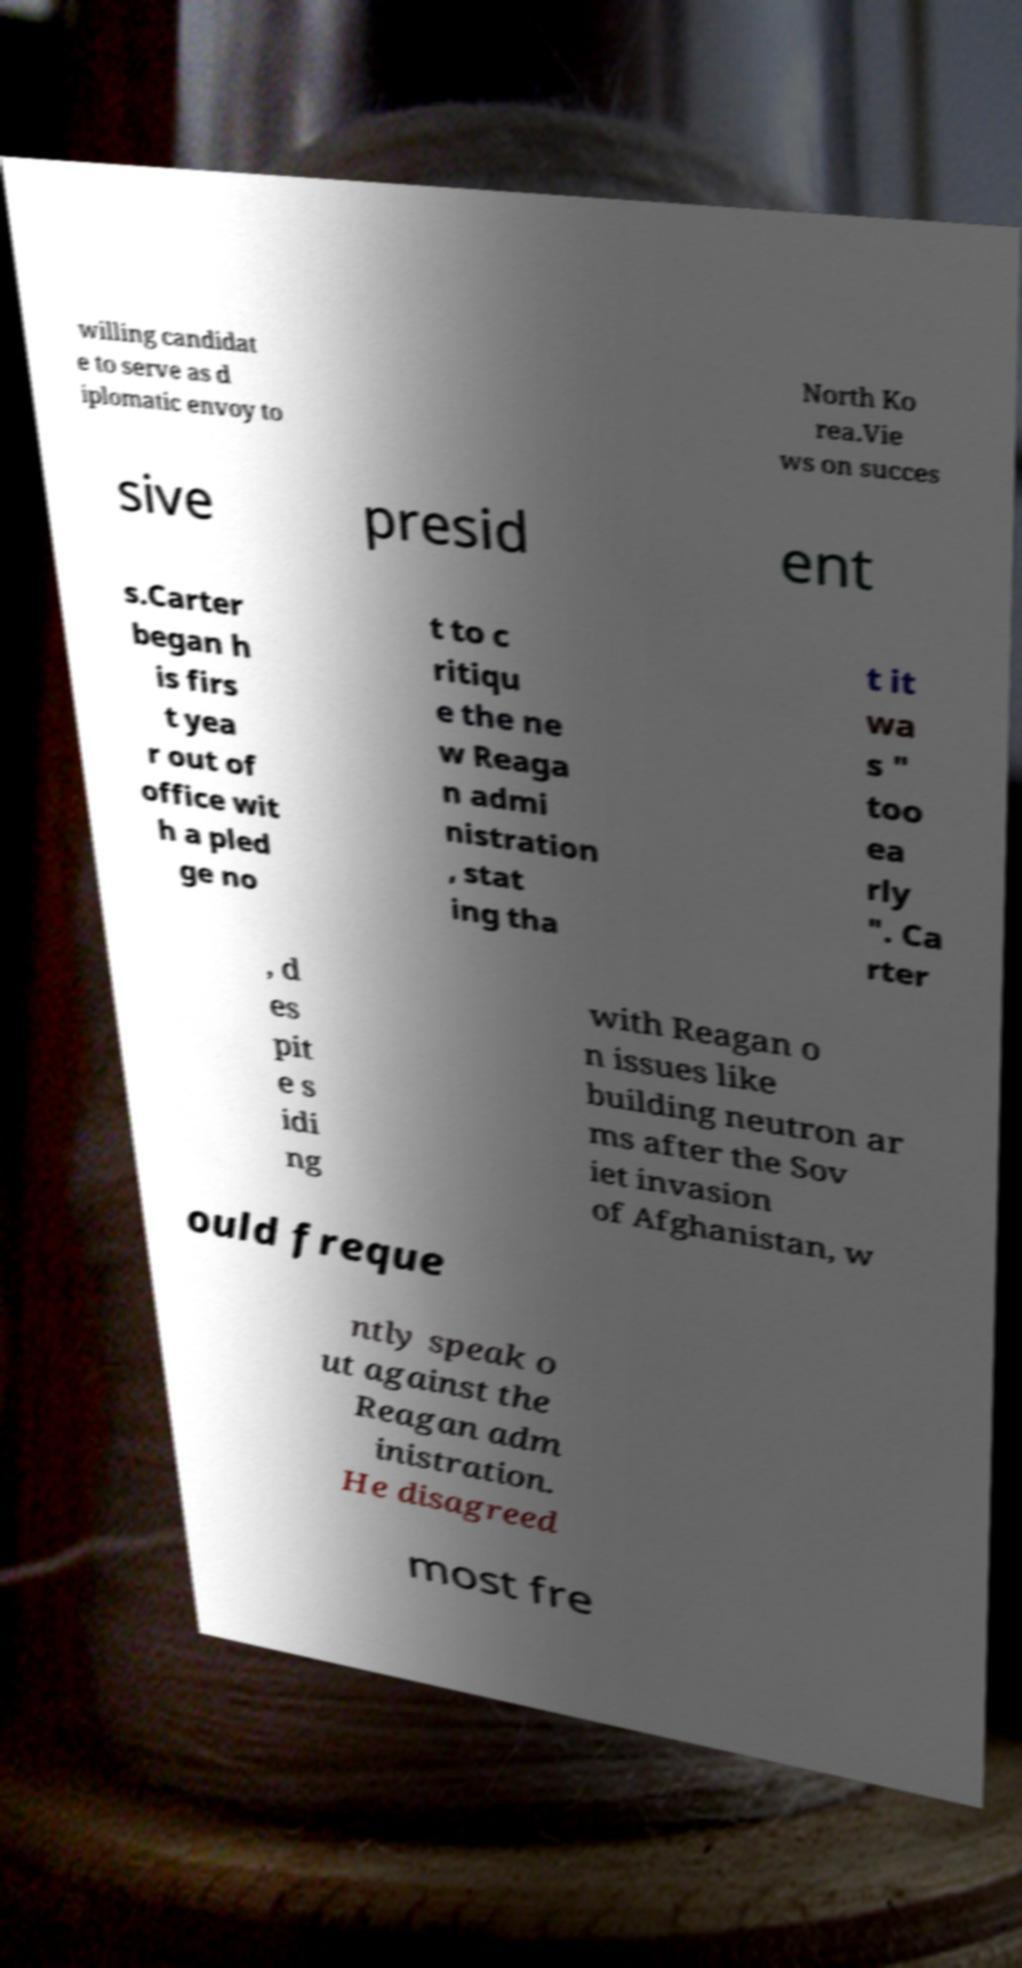Please identify and transcribe the text found in this image. willing candidat e to serve as d iplomatic envoy to North Ko rea.Vie ws on succes sive presid ent s.Carter began h is firs t yea r out of office wit h a pled ge no t to c ritiqu e the ne w Reaga n admi nistration , stat ing tha t it wa s " too ea rly ". Ca rter , d es pit e s idi ng with Reagan o n issues like building neutron ar ms after the Sov iet invasion of Afghanistan, w ould freque ntly speak o ut against the Reagan adm inistration. He disagreed most fre 